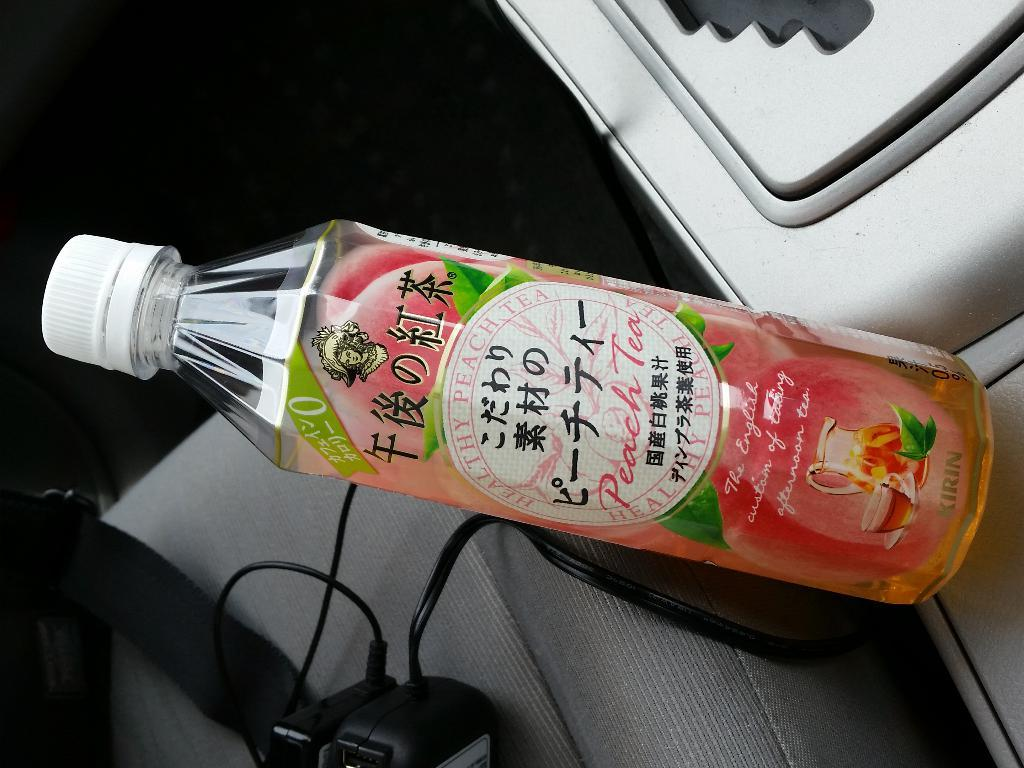What object can be seen in the image with a sticker on it? There is a bottle in the image with a sticker on it. Where is the bottle located in the image? The bottle is on a chair. What else can be seen on the chair in the image? There are cables and other items on the chair. What time does the watch on the chair display in the image? There is no watch present in the image. 